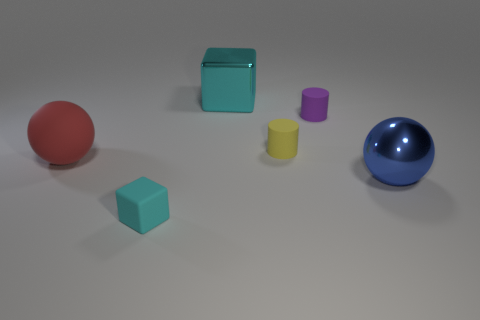There is a blue metallic ball; is it the same size as the cyan block on the right side of the small cyan matte object?
Provide a short and direct response. Yes. There is a cyan object that is behind the block that is in front of the cyan metal cube; what is its shape?
Keep it short and to the point. Cube. Are there fewer blue things that are behind the purple matte thing than big yellow things?
Keep it short and to the point. No. What shape is the small rubber thing that is the same color as the shiny cube?
Keep it short and to the point. Cube. What number of red things have the same size as the yellow cylinder?
Your answer should be very brief. 0. The cyan object left of the big block has what shape?
Ensure brevity in your answer.  Cube. Is the number of big blue objects less than the number of matte objects?
Ensure brevity in your answer.  Yes. Are there any other things that are the same color as the big cube?
Your response must be concise. Yes. There is a cyan thing behind the rubber block; what size is it?
Provide a succinct answer. Large. Is the number of small yellow things greater than the number of cyan objects?
Ensure brevity in your answer.  No. 